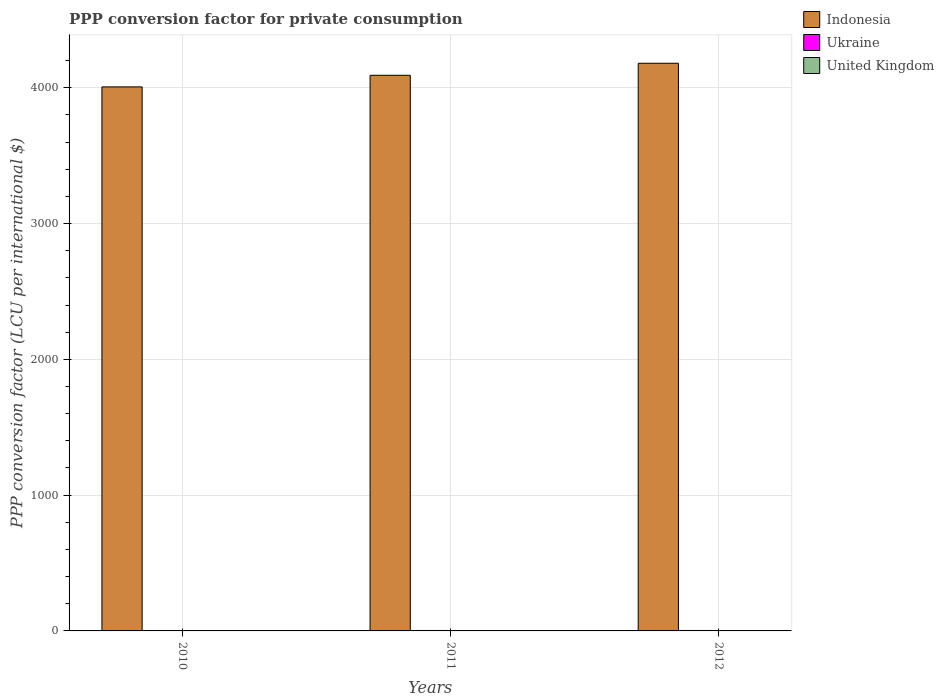How many groups of bars are there?
Provide a short and direct response. 3. How many bars are there on the 2nd tick from the left?
Your answer should be compact. 3. How many bars are there on the 2nd tick from the right?
Make the answer very short. 3. In how many cases, is the number of bars for a given year not equal to the number of legend labels?
Your answer should be very brief. 0. What is the PPP conversion factor for private consumption in United Kingdom in 2012?
Your answer should be very brief. 0.77. Across all years, what is the maximum PPP conversion factor for private consumption in United Kingdom?
Ensure brevity in your answer.  0.77. Across all years, what is the minimum PPP conversion factor for private consumption in United Kingdom?
Ensure brevity in your answer.  0.75. In which year was the PPP conversion factor for private consumption in United Kingdom maximum?
Keep it short and to the point. 2012. What is the total PPP conversion factor for private consumption in United Kingdom in the graph?
Keep it short and to the point. 2.28. What is the difference between the PPP conversion factor for private consumption in Indonesia in 2011 and that in 2012?
Offer a very short reply. -88.61. What is the difference between the PPP conversion factor for private consumption in United Kingdom in 2010 and the PPP conversion factor for private consumption in Indonesia in 2012?
Ensure brevity in your answer.  -4179.79. What is the average PPP conversion factor for private consumption in Indonesia per year?
Provide a succinct answer. 4092.98. In the year 2012, what is the difference between the PPP conversion factor for private consumption in United Kingdom and PPP conversion factor for private consumption in Indonesia?
Your answer should be very brief. -4179.78. What is the ratio of the PPP conversion factor for private consumption in Indonesia in 2010 to that in 2011?
Provide a short and direct response. 0.98. Is the difference between the PPP conversion factor for private consumption in United Kingdom in 2011 and 2012 greater than the difference between the PPP conversion factor for private consumption in Indonesia in 2011 and 2012?
Provide a succinct answer. Yes. What is the difference between the highest and the second highest PPP conversion factor for private consumption in United Kingdom?
Offer a very short reply. 0.01. What is the difference between the highest and the lowest PPP conversion factor for private consumption in Indonesia?
Offer a terse response. 174.08. In how many years, is the PPP conversion factor for private consumption in United Kingdom greater than the average PPP conversion factor for private consumption in United Kingdom taken over all years?
Keep it short and to the point. 2. Is the sum of the PPP conversion factor for private consumption in Indonesia in 2010 and 2011 greater than the maximum PPP conversion factor for private consumption in United Kingdom across all years?
Ensure brevity in your answer.  Yes. What does the 2nd bar from the right in 2012 represents?
Your response must be concise. Ukraine. How many bars are there?
Your answer should be compact. 9. Are all the bars in the graph horizontal?
Your answer should be compact. No. How many years are there in the graph?
Your response must be concise. 3. What is the difference between two consecutive major ticks on the Y-axis?
Offer a terse response. 1000. Are the values on the major ticks of Y-axis written in scientific E-notation?
Keep it short and to the point. No. Does the graph contain any zero values?
Your response must be concise. No. How are the legend labels stacked?
Make the answer very short. Vertical. What is the title of the graph?
Offer a terse response. PPP conversion factor for private consumption. What is the label or title of the X-axis?
Offer a terse response. Years. What is the label or title of the Y-axis?
Keep it short and to the point. PPP conversion factor (LCU per international $). What is the PPP conversion factor (LCU per international $) of Indonesia in 2010?
Offer a very short reply. 4006.47. What is the PPP conversion factor (LCU per international $) of Ukraine in 2010?
Make the answer very short. 3.16. What is the PPP conversion factor (LCU per international $) of United Kingdom in 2010?
Make the answer very short. 0.75. What is the PPP conversion factor (LCU per international $) of Indonesia in 2011?
Your answer should be very brief. 4091.94. What is the PPP conversion factor (LCU per international $) of Ukraine in 2011?
Your answer should be compact. 3.31. What is the PPP conversion factor (LCU per international $) in United Kingdom in 2011?
Offer a very short reply. 0.76. What is the PPP conversion factor (LCU per international $) of Indonesia in 2012?
Offer a very short reply. 4180.54. What is the PPP conversion factor (LCU per international $) in Ukraine in 2012?
Give a very brief answer. 3.26. What is the PPP conversion factor (LCU per international $) in United Kingdom in 2012?
Your answer should be very brief. 0.77. Across all years, what is the maximum PPP conversion factor (LCU per international $) of Indonesia?
Make the answer very short. 4180.54. Across all years, what is the maximum PPP conversion factor (LCU per international $) in Ukraine?
Offer a terse response. 3.31. Across all years, what is the maximum PPP conversion factor (LCU per international $) in United Kingdom?
Offer a very short reply. 0.77. Across all years, what is the minimum PPP conversion factor (LCU per international $) of Indonesia?
Make the answer very short. 4006.47. Across all years, what is the minimum PPP conversion factor (LCU per international $) in Ukraine?
Keep it short and to the point. 3.16. Across all years, what is the minimum PPP conversion factor (LCU per international $) of United Kingdom?
Your answer should be very brief. 0.75. What is the total PPP conversion factor (LCU per international $) in Indonesia in the graph?
Give a very brief answer. 1.23e+04. What is the total PPP conversion factor (LCU per international $) of Ukraine in the graph?
Keep it short and to the point. 9.74. What is the total PPP conversion factor (LCU per international $) of United Kingdom in the graph?
Your response must be concise. 2.28. What is the difference between the PPP conversion factor (LCU per international $) in Indonesia in 2010 and that in 2011?
Offer a terse response. -85.47. What is the difference between the PPP conversion factor (LCU per international $) of Ukraine in 2010 and that in 2011?
Your answer should be very brief. -0.15. What is the difference between the PPP conversion factor (LCU per international $) of United Kingdom in 2010 and that in 2011?
Provide a short and direct response. -0.01. What is the difference between the PPP conversion factor (LCU per international $) of Indonesia in 2010 and that in 2012?
Your response must be concise. -174.08. What is the difference between the PPP conversion factor (LCU per international $) of Ukraine in 2010 and that in 2012?
Keep it short and to the point. -0.1. What is the difference between the PPP conversion factor (LCU per international $) in United Kingdom in 2010 and that in 2012?
Keep it short and to the point. -0.02. What is the difference between the PPP conversion factor (LCU per international $) of Indonesia in 2011 and that in 2012?
Offer a very short reply. -88.61. What is the difference between the PPP conversion factor (LCU per international $) of Ukraine in 2011 and that in 2012?
Provide a succinct answer. 0.05. What is the difference between the PPP conversion factor (LCU per international $) of United Kingdom in 2011 and that in 2012?
Provide a short and direct response. -0.01. What is the difference between the PPP conversion factor (LCU per international $) in Indonesia in 2010 and the PPP conversion factor (LCU per international $) in Ukraine in 2011?
Make the answer very short. 4003.16. What is the difference between the PPP conversion factor (LCU per international $) in Indonesia in 2010 and the PPP conversion factor (LCU per international $) in United Kingdom in 2011?
Your response must be concise. 4005.71. What is the difference between the PPP conversion factor (LCU per international $) of Ukraine in 2010 and the PPP conversion factor (LCU per international $) of United Kingdom in 2011?
Provide a short and direct response. 2.4. What is the difference between the PPP conversion factor (LCU per international $) of Indonesia in 2010 and the PPP conversion factor (LCU per international $) of Ukraine in 2012?
Ensure brevity in your answer.  4003.21. What is the difference between the PPP conversion factor (LCU per international $) in Indonesia in 2010 and the PPP conversion factor (LCU per international $) in United Kingdom in 2012?
Your answer should be compact. 4005.7. What is the difference between the PPP conversion factor (LCU per international $) in Ukraine in 2010 and the PPP conversion factor (LCU per international $) in United Kingdom in 2012?
Ensure brevity in your answer.  2.4. What is the difference between the PPP conversion factor (LCU per international $) in Indonesia in 2011 and the PPP conversion factor (LCU per international $) in Ukraine in 2012?
Your response must be concise. 4088.68. What is the difference between the PPP conversion factor (LCU per international $) in Indonesia in 2011 and the PPP conversion factor (LCU per international $) in United Kingdom in 2012?
Make the answer very short. 4091.17. What is the difference between the PPP conversion factor (LCU per international $) of Ukraine in 2011 and the PPP conversion factor (LCU per international $) of United Kingdom in 2012?
Offer a terse response. 2.54. What is the average PPP conversion factor (LCU per international $) of Indonesia per year?
Ensure brevity in your answer.  4092.98. What is the average PPP conversion factor (LCU per international $) in Ukraine per year?
Your answer should be very brief. 3.25. What is the average PPP conversion factor (LCU per international $) in United Kingdom per year?
Make the answer very short. 0.76. In the year 2010, what is the difference between the PPP conversion factor (LCU per international $) in Indonesia and PPP conversion factor (LCU per international $) in Ukraine?
Offer a very short reply. 4003.3. In the year 2010, what is the difference between the PPP conversion factor (LCU per international $) of Indonesia and PPP conversion factor (LCU per international $) of United Kingdom?
Offer a terse response. 4005.72. In the year 2010, what is the difference between the PPP conversion factor (LCU per international $) of Ukraine and PPP conversion factor (LCU per international $) of United Kingdom?
Provide a succinct answer. 2.41. In the year 2011, what is the difference between the PPP conversion factor (LCU per international $) in Indonesia and PPP conversion factor (LCU per international $) in Ukraine?
Your answer should be compact. 4088.63. In the year 2011, what is the difference between the PPP conversion factor (LCU per international $) in Indonesia and PPP conversion factor (LCU per international $) in United Kingdom?
Provide a succinct answer. 4091.18. In the year 2011, what is the difference between the PPP conversion factor (LCU per international $) in Ukraine and PPP conversion factor (LCU per international $) in United Kingdom?
Make the answer very short. 2.55. In the year 2012, what is the difference between the PPP conversion factor (LCU per international $) of Indonesia and PPP conversion factor (LCU per international $) of Ukraine?
Provide a short and direct response. 4177.28. In the year 2012, what is the difference between the PPP conversion factor (LCU per international $) in Indonesia and PPP conversion factor (LCU per international $) in United Kingdom?
Keep it short and to the point. 4179.78. In the year 2012, what is the difference between the PPP conversion factor (LCU per international $) in Ukraine and PPP conversion factor (LCU per international $) in United Kingdom?
Make the answer very short. 2.5. What is the ratio of the PPP conversion factor (LCU per international $) in Indonesia in 2010 to that in 2011?
Your answer should be compact. 0.98. What is the ratio of the PPP conversion factor (LCU per international $) of Ukraine in 2010 to that in 2011?
Your response must be concise. 0.96. What is the ratio of the PPP conversion factor (LCU per international $) in United Kingdom in 2010 to that in 2011?
Offer a very short reply. 0.99. What is the ratio of the PPP conversion factor (LCU per international $) in Indonesia in 2010 to that in 2012?
Your answer should be very brief. 0.96. What is the ratio of the PPP conversion factor (LCU per international $) in Ukraine in 2010 to that in 2012?
Your answer should be compact. 0.97. What is the ratio of the PPP conversion factor (LCU per international $) in United Kingdom in 2010 to that in 2012?
Your response must be concise. 0.98. What is the ratio of the PPP conversion factor (LCU per international $) in Indonesia in 2011 to that in 2012?
Keep it short and to the point. 0.98. What is the ratio of the PPP conversion factor (LCU per international $) of Ukraine in 2011 to that in 2012?
Provide a succinct answer. 1.02. What is the ratio of the PPP conversion factor (LCU per international $) in United Kingdom in 2011 to that in 2012?
Make the answer very short. 0.99. What is the difference between the highest and the second highest PPP conversion factor (LCU per international $) of Indonesia?
Keep it short and to the point. 88.61. What is the difference between the highest and the second highest PPP conversion factor (LCU per international $) in Ukraine?
Your answer should be compact. 0.05. What is the difference between the highest and the second highest PPP conversion factor (LCU per international $) of United Kingdom?
Provide a succinct answer. 0.01. What is the difference between the highest and the lowest PPP conversion factor (LCU per international $) of Indonesia?
Your answer should be very brief. 174.08. What is the difference between the highest and the lowest PPP conversion factor (LCU per international $) in Ukraine?
Make the answer very short. 0.15. What is the difference between the highest and the lowest PPP conversion factor (LCU per international $) in United Kingdom?
Ensure brevity in your answer.  0.02. 